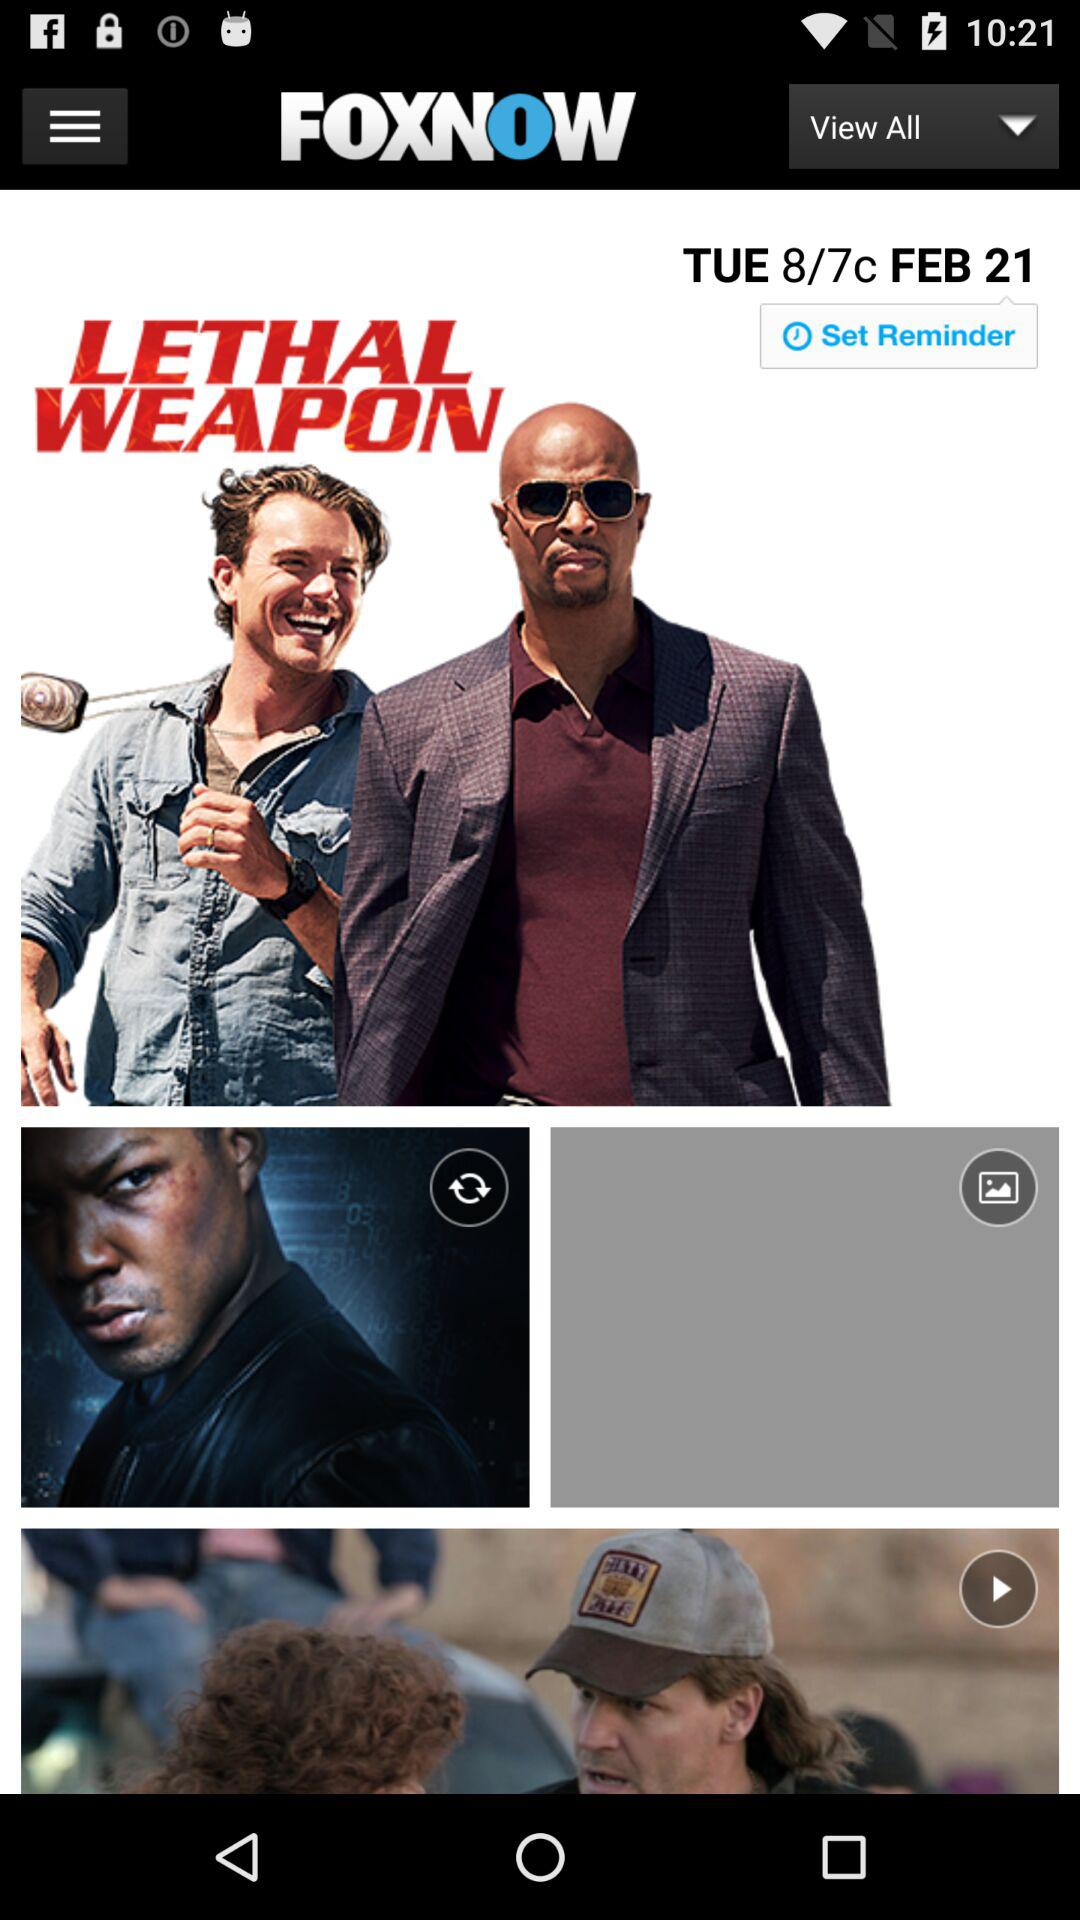What is the name of the movie? The name of the movie is "LETHAL WEAPON". 